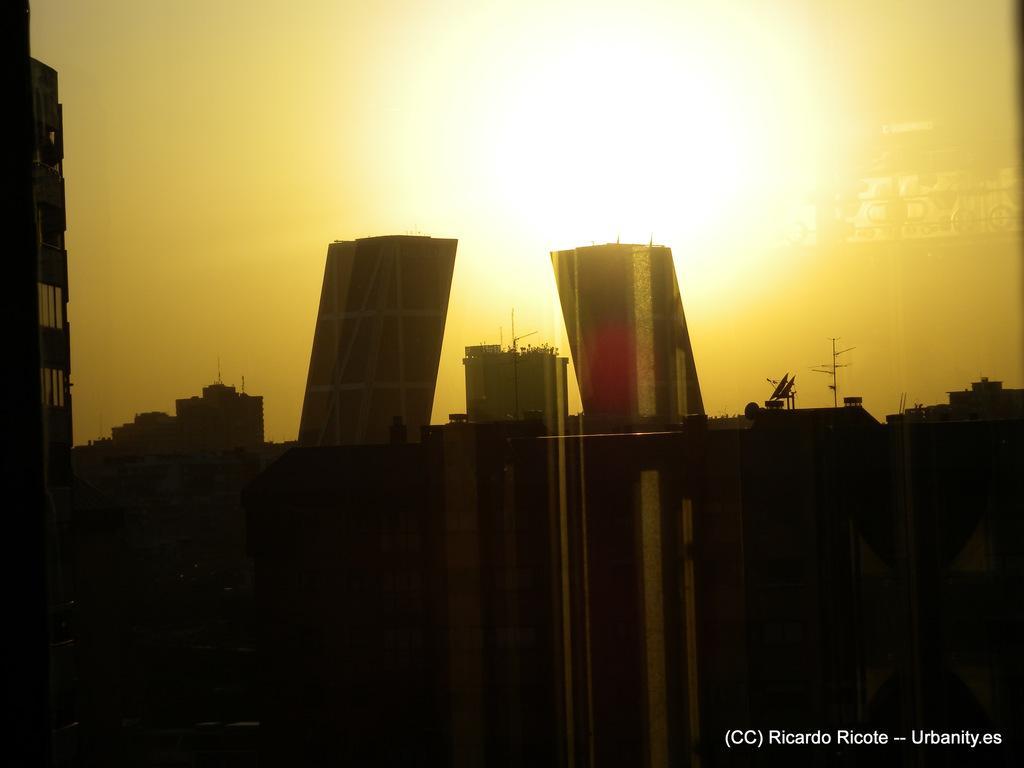Could you give a brief overview of what you see in this image? In the image there are many buildings. And also there are dishes of tv antenna and poles. At the top of the image there is a sky with sun. In the bottom right corner of the image there is a name. 